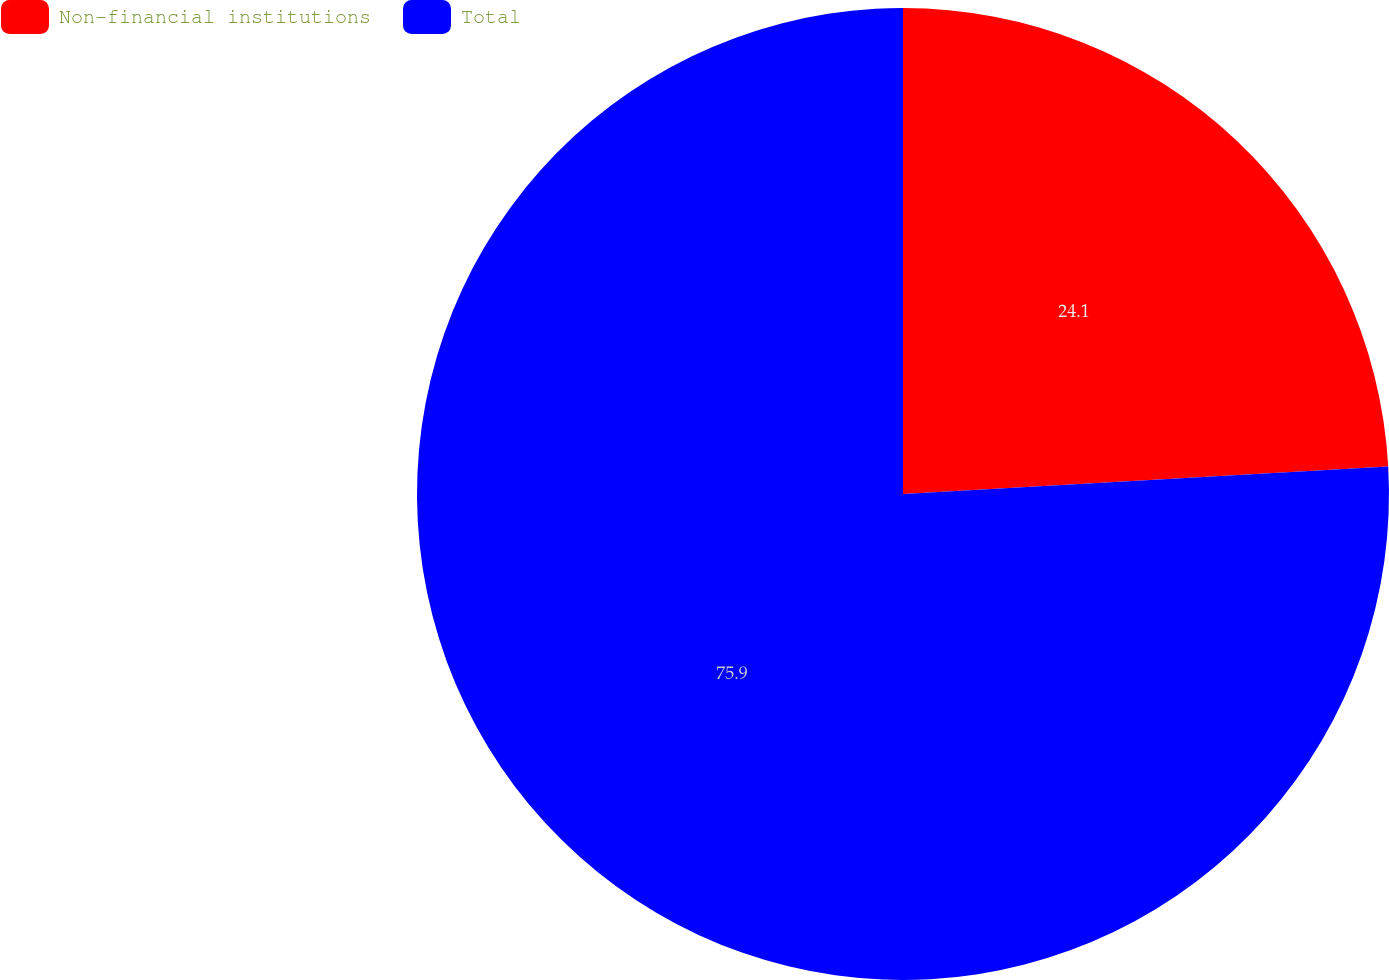Convert chart to OTSL. <chart><loc_0><loc_0><loc_500><loc_500><pie_chart><fcel>Non-financial institutions<fcel>Total<nl><fcel>24.1%<fcel>75.9%<nl></chart> 